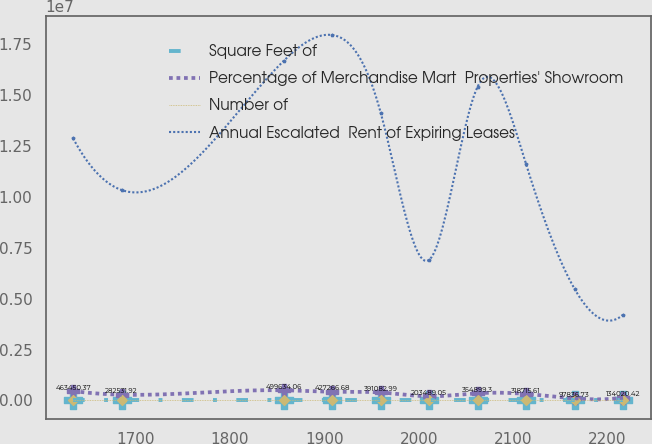Convert chart. <chart><loc_0><loc_0><loc_500><loc_500><line_chart><ecel><fcel>Square Feet of<fcel>Percentage of Merchandise Mart  Properties' Showroom<fcel>Number of<fcel>Annual Escalated  Rent of Expiring Leases<nl><fcel>1633.81<fcel>155.1<fcel>463450<fcel>10.09<fcel>1.28817e+07<nl><fcel>1685.18<fcel>132.98<fcel>282532<fcel>9.15<fcel>1.03426e+07<nl><fcel>1856.97<fcel>144.04<fcel>499634<fcel>11.97<fcel>1.66902e+07<nl><fcel>1908.34<fcel>121.92<fcel>427267<fcel>11.03<fcel>1.79597e+07<nl><fcel>1959.71<fcel>88.91<fcel>391083<fcel>6.33<fcel>1.41512e+07<nl><fcel>2011.08<fcel>54.18<fcel>203489<fcel>5.39<fcel>6.90708e+06<nl><fcel>2062.45<fcel>65.24<fcel>354899<fcel>8.21<fcel>1.54207e+07<nl><fcel>2113.82<fcel>43.12<fcel>318716<fcel>7.27<fcel>1.16122e+07<nl><fcel>2165.19<fcel>21<fcel>97836.7<fcel>2.11<fcel>5.48092e+06<nl><fcel>2216.56<fcel>32.06<fcel>134020<fcel>3.05<fcel>4.21141e+06<nl></chart> 